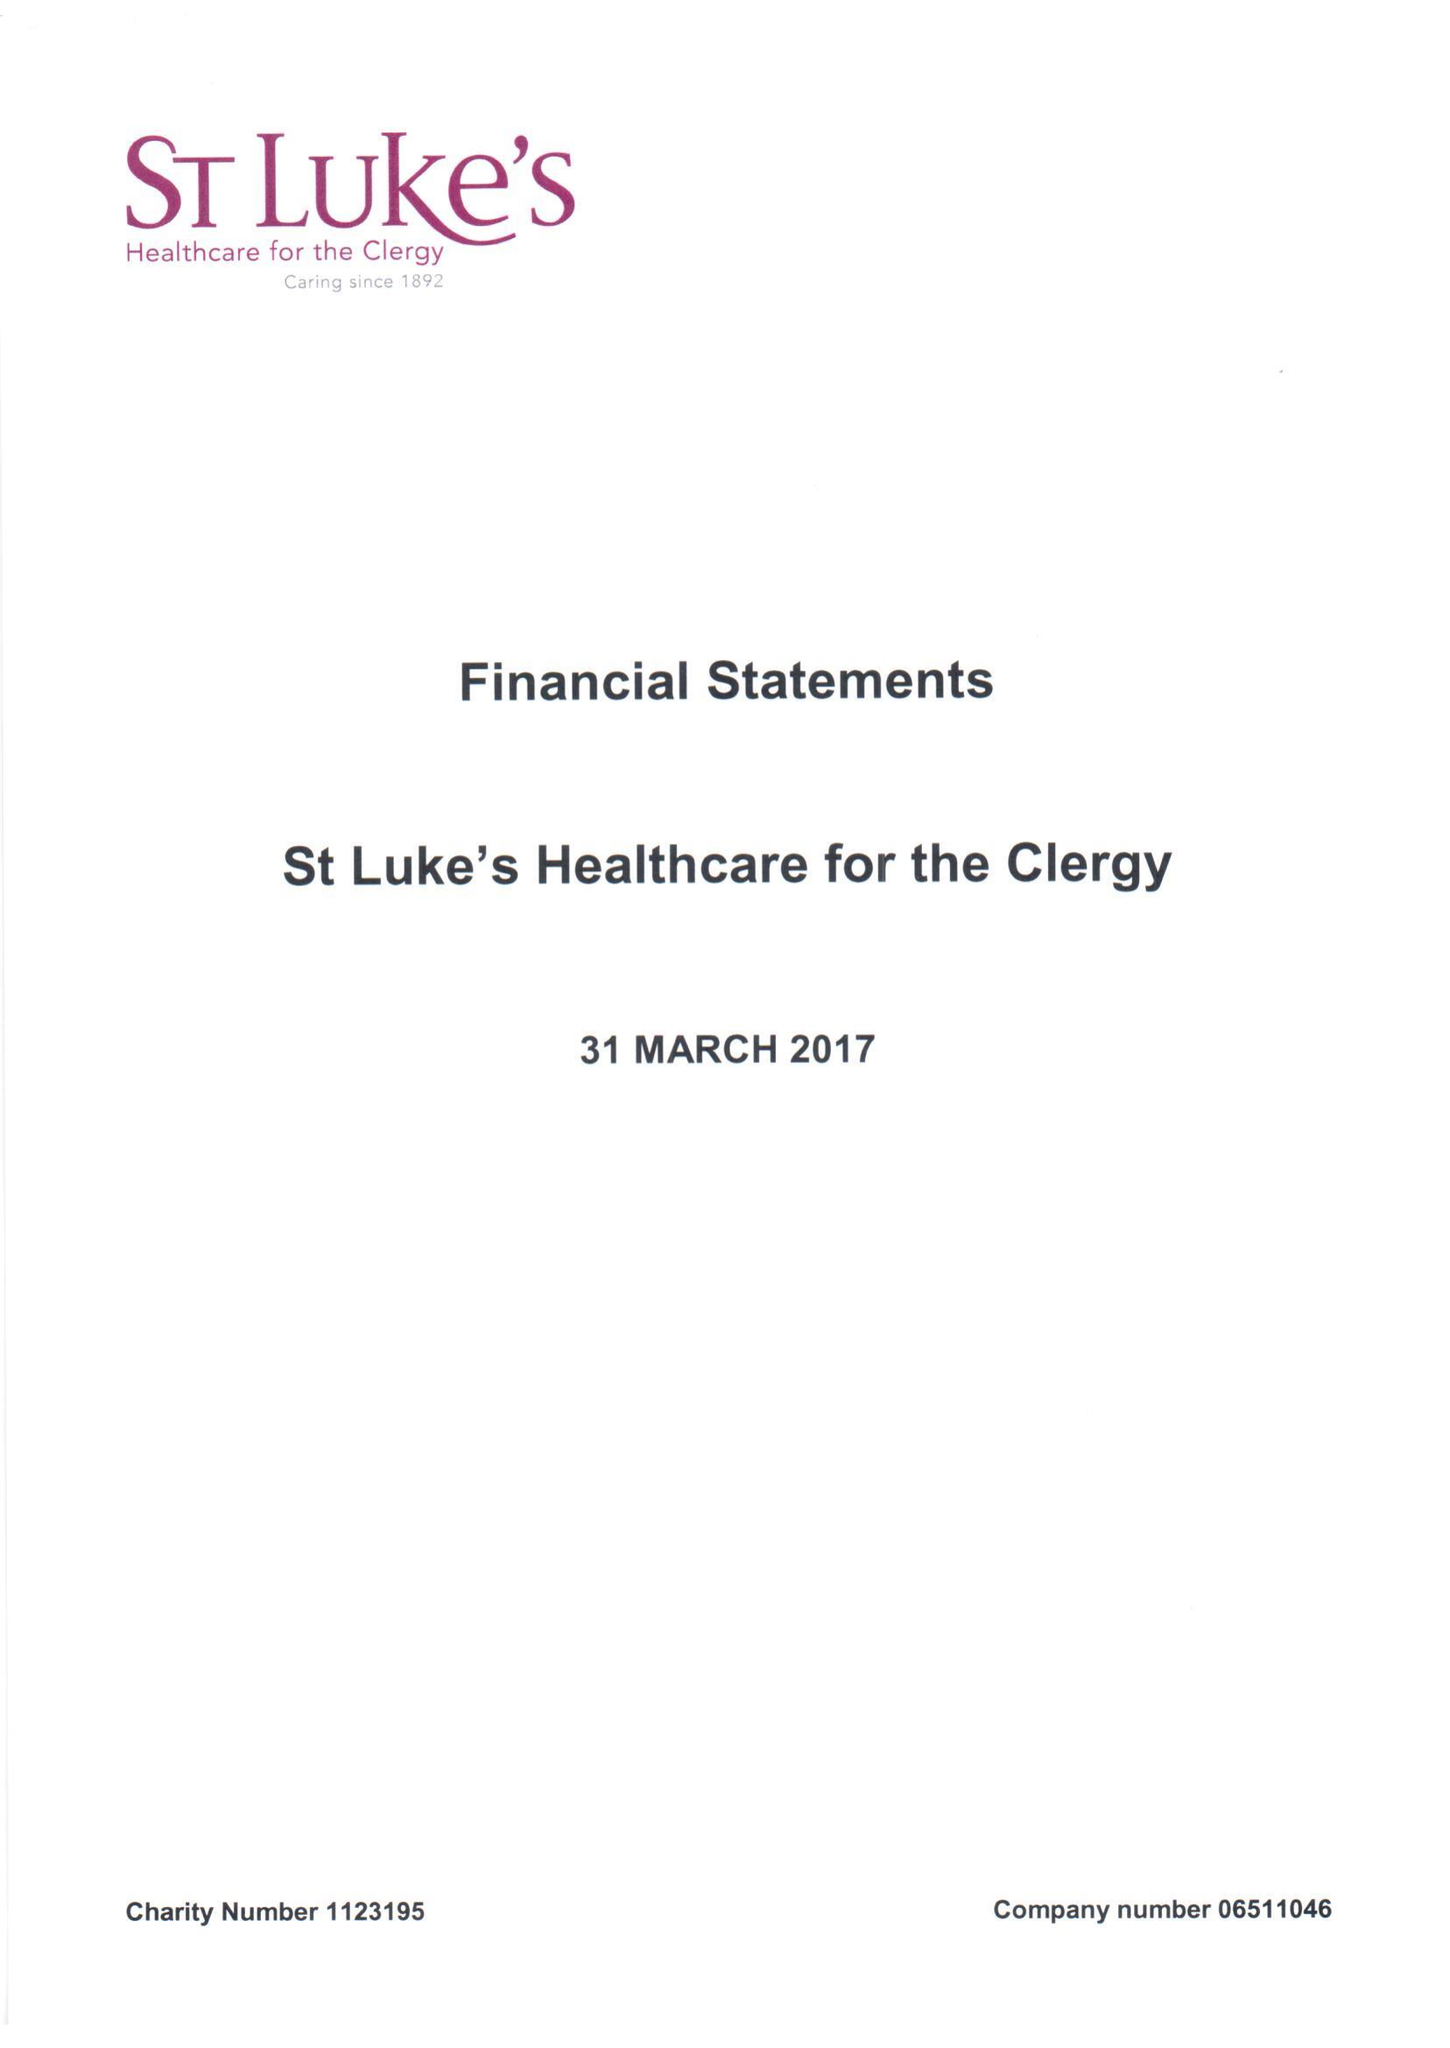What is the value for the address__post_town?
Answer the question using a single word or phrase. LONDON 